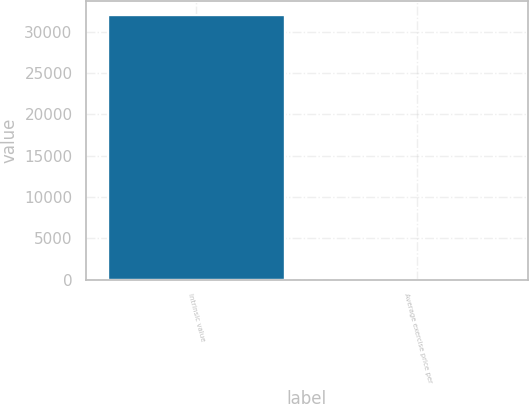Convert chart. <chart><loc_0><loc_0><loc_500><loc_500><bar_chart><fcel>Intrinsic value<fcel>Average exercise price per<nl><fcel>32094<fcel>24.47<nl></chart> 